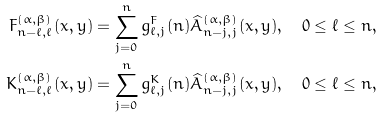Convert formula to latex. <formula><loc_0><loc_0><loc_500><loc_500>F _ { n - \ell , \ell } ^ { ( \alpha , \beta ) } ( x , y ) & = \sum _ { j = 0 } ^ { n } g _ { \ell , j } ^ { F } ( n ) { \widehat { A } } _ { n - j , j } ^ { ( \alpha , \beta ) } ( x , y ) , \quad 0 \leq \ell \leq n , \\ K _ { n - \ell , \ell } ^ { ( \alpha , \beta ) } ( x , y ) & = \sum _ { j = 0 } ^ { n } g _ { \ell , j } ^ { K } ( n ) { \widehat { A } } _ { n - j , j } ^ { ( \alpha , \beta ) } ( x , y ) , \quad 0 \leq \ell \leq n ,</formula> 